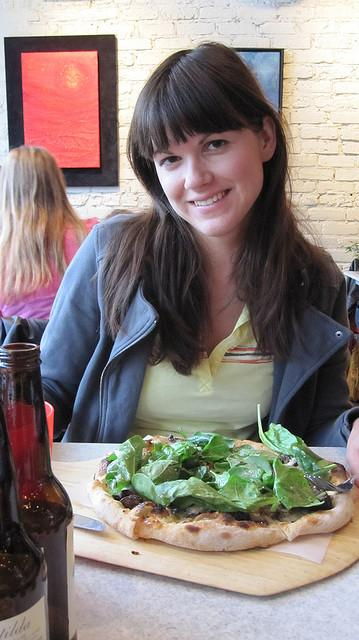What is adorning the pizza?

Choices:
A) cherries
B) anchovies
C) meatballs
D) lettuce lettuce 